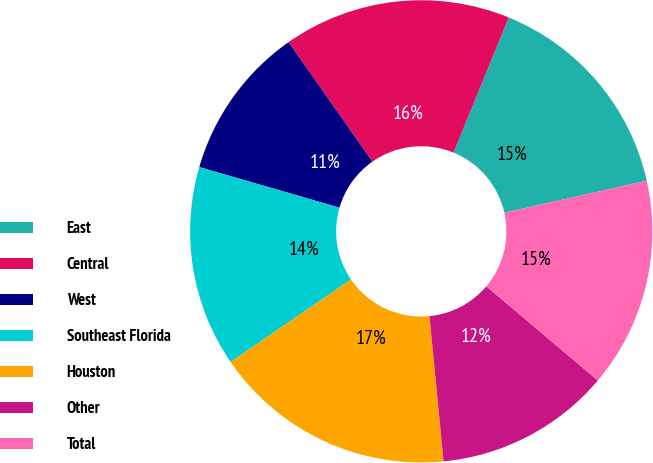Convert chart to OTSL. <chart><loc_0><loc_0><loc_500><loc_500><pie_chart><fcel>East<fcel>Central<fcel>West<fcel>Southeast Florida<fcel>Houston<fcel>Other<fcel>Total<nl><fcel>15.3%<fcel>15.92%<fcel>10.78%<fcel>14.05%<fcel>16.98%<fcel>12.3%<fcel>14.68%<nl></chart> 